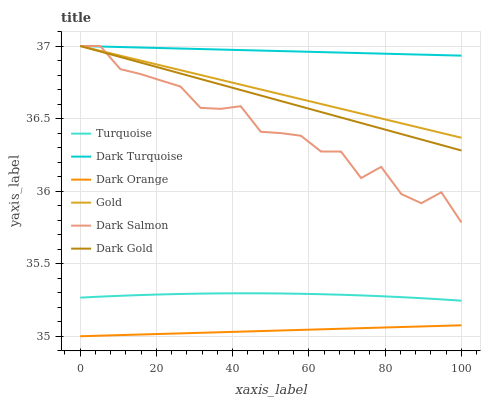Does Dark Orange have the minimum area under the curve?
Answer yes or no. Yes. Does Dark Turquoise have the maximum area under the curve?
Answer yes or no. Yes. Does Turquoise have the minimum area under the curve?
Answer yes or no. No. Does Turquoise have the maximum area under the curve?
Answer yes or no. No. Is Dark Gold the smoothest?
Answer yes or no. Yes. Is Dark Salmon the roughest?
Answer yes or no. Yes. Is Turquoise the smoothest?
Answer yes or no. No. Is Turquoise the roughest?
Answer yes or no. No. Does Dark Orange have the lowest value?
Answer yes or no. Yes. Does Turquoise have the lowest value?
Answer yes or no. No. Does Dark Salmon have the highest value?
Answer yes or no. Yes. Does Turquoise have the highest value?
Answer yes or no. No. Is Dark Orange less than Dark Turquoise?
Answer yes or no. Yes. Is Gold greater than Turquoise?
Answer yes or no. Yes. Does Dark Gold intersect Dark Turquoise?
Answer yes or no. Yes. Is Dark Gold less than Dark Turquoise?
Answer yes or no. No. Is Dark Gold greater than Dark Turquoise?
Answer yes or no. No. Does Dark Orange intersect Dark Turquoise?
Answer yes or no. No. 